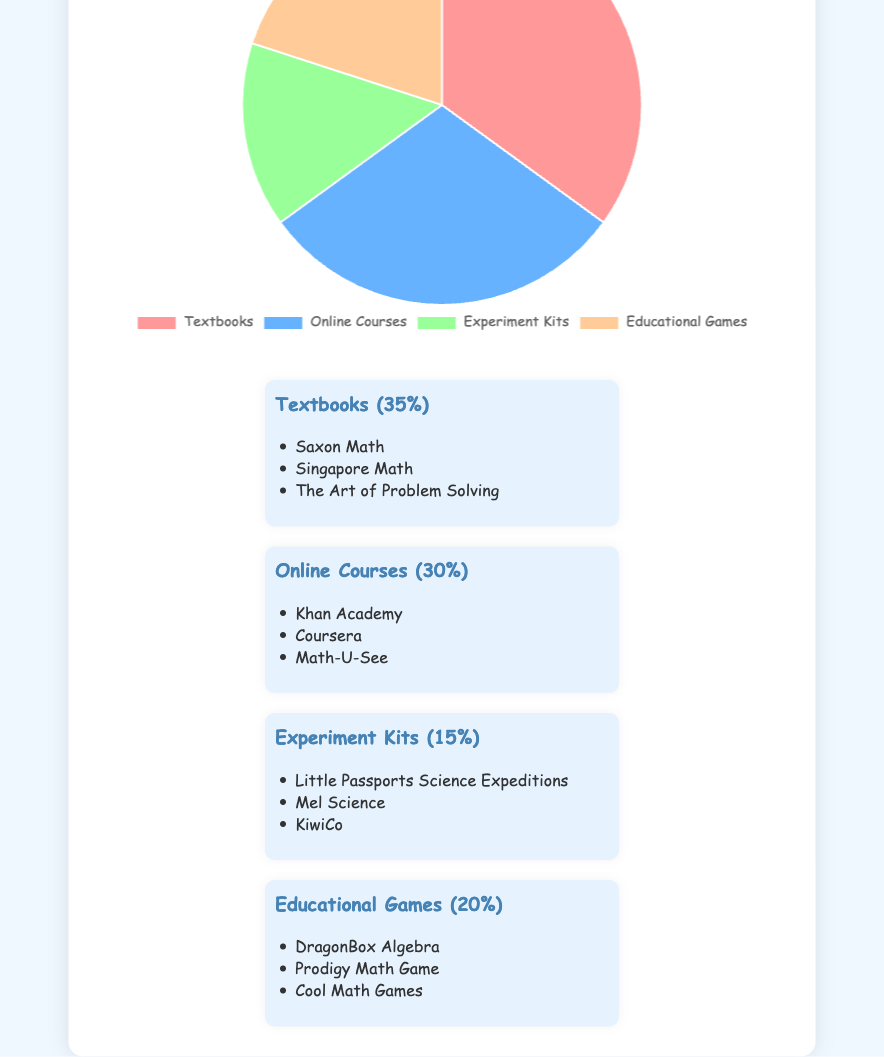Which type of educational resource is most commonly used? By looking at the pie chart, we can identify the resource with the largest segment. In this case, "Textbooks" has the largest proportion, representing 35% of the total.
Answer: Textbooks What is the combined percentage of usage for Online Courses and Educational Games? To find the combined percentage, add the percentages of Online Courses and Educational Games: 30% + 20% = 50%.
Answer: 50% Which category has the smallest segment in the pie chart? The smallest segment in the pie chart is "Experiment Kits," with a percentage of 15%.
Answer: Experiment Kits How much greater is the percentage of Textbooks compared to Experiment Kits? The percentage of Textbooks is 35%, and the percentage of Experiment Kits is 15%. Subtract 15% from 35% to get the difference: 35% - 15% = 20%.
Answer: 20% If Educational Games usage increased by 10%, what would their new percentage be? Educational Games currently represent 20%. If we increase this by 10%, we add 10% to 20%, resulting in 20% + 10% = 30%.
Answer: 30% How does the usage of Online Courses compare to that of Textbooks? Comparing the percentages, Online Courses represent 30% and Textbooks represent 35%. Online Courses are 5% less popular than Textbooks.
Answer: Online Courses are 5% less What is the total percentage of resources used for Textbooks, Experiment Kits, and Educational Games combined? Add the percentages for Textbooks (35%), Experiment Kits (15%), and Educational Games (20%): 35% + 15% + 20% = 70%.
Answer: 70% What color represents Educational Games in the pie chart? The visual representation in the pie chart indicates that Educational Games are shown in the color orange.
Answer: Orange If you were to add a new resource category that takes up 10% of the total, what would the remaining percentage be for the existing categories? The current total percentage for all resources is 100%. Subtracting the new category's 10% from 100% leaves 90% for the existing categories.
Answer: 90% What is the difference between the highest and the lowest percentages of resource usage? The highest percentage is Textbooks at 35% and the lowest is Experiment Kits at 15%. Subtracting 15% from 35% gives 35% - 15% = 20%.
Answer: 20% 